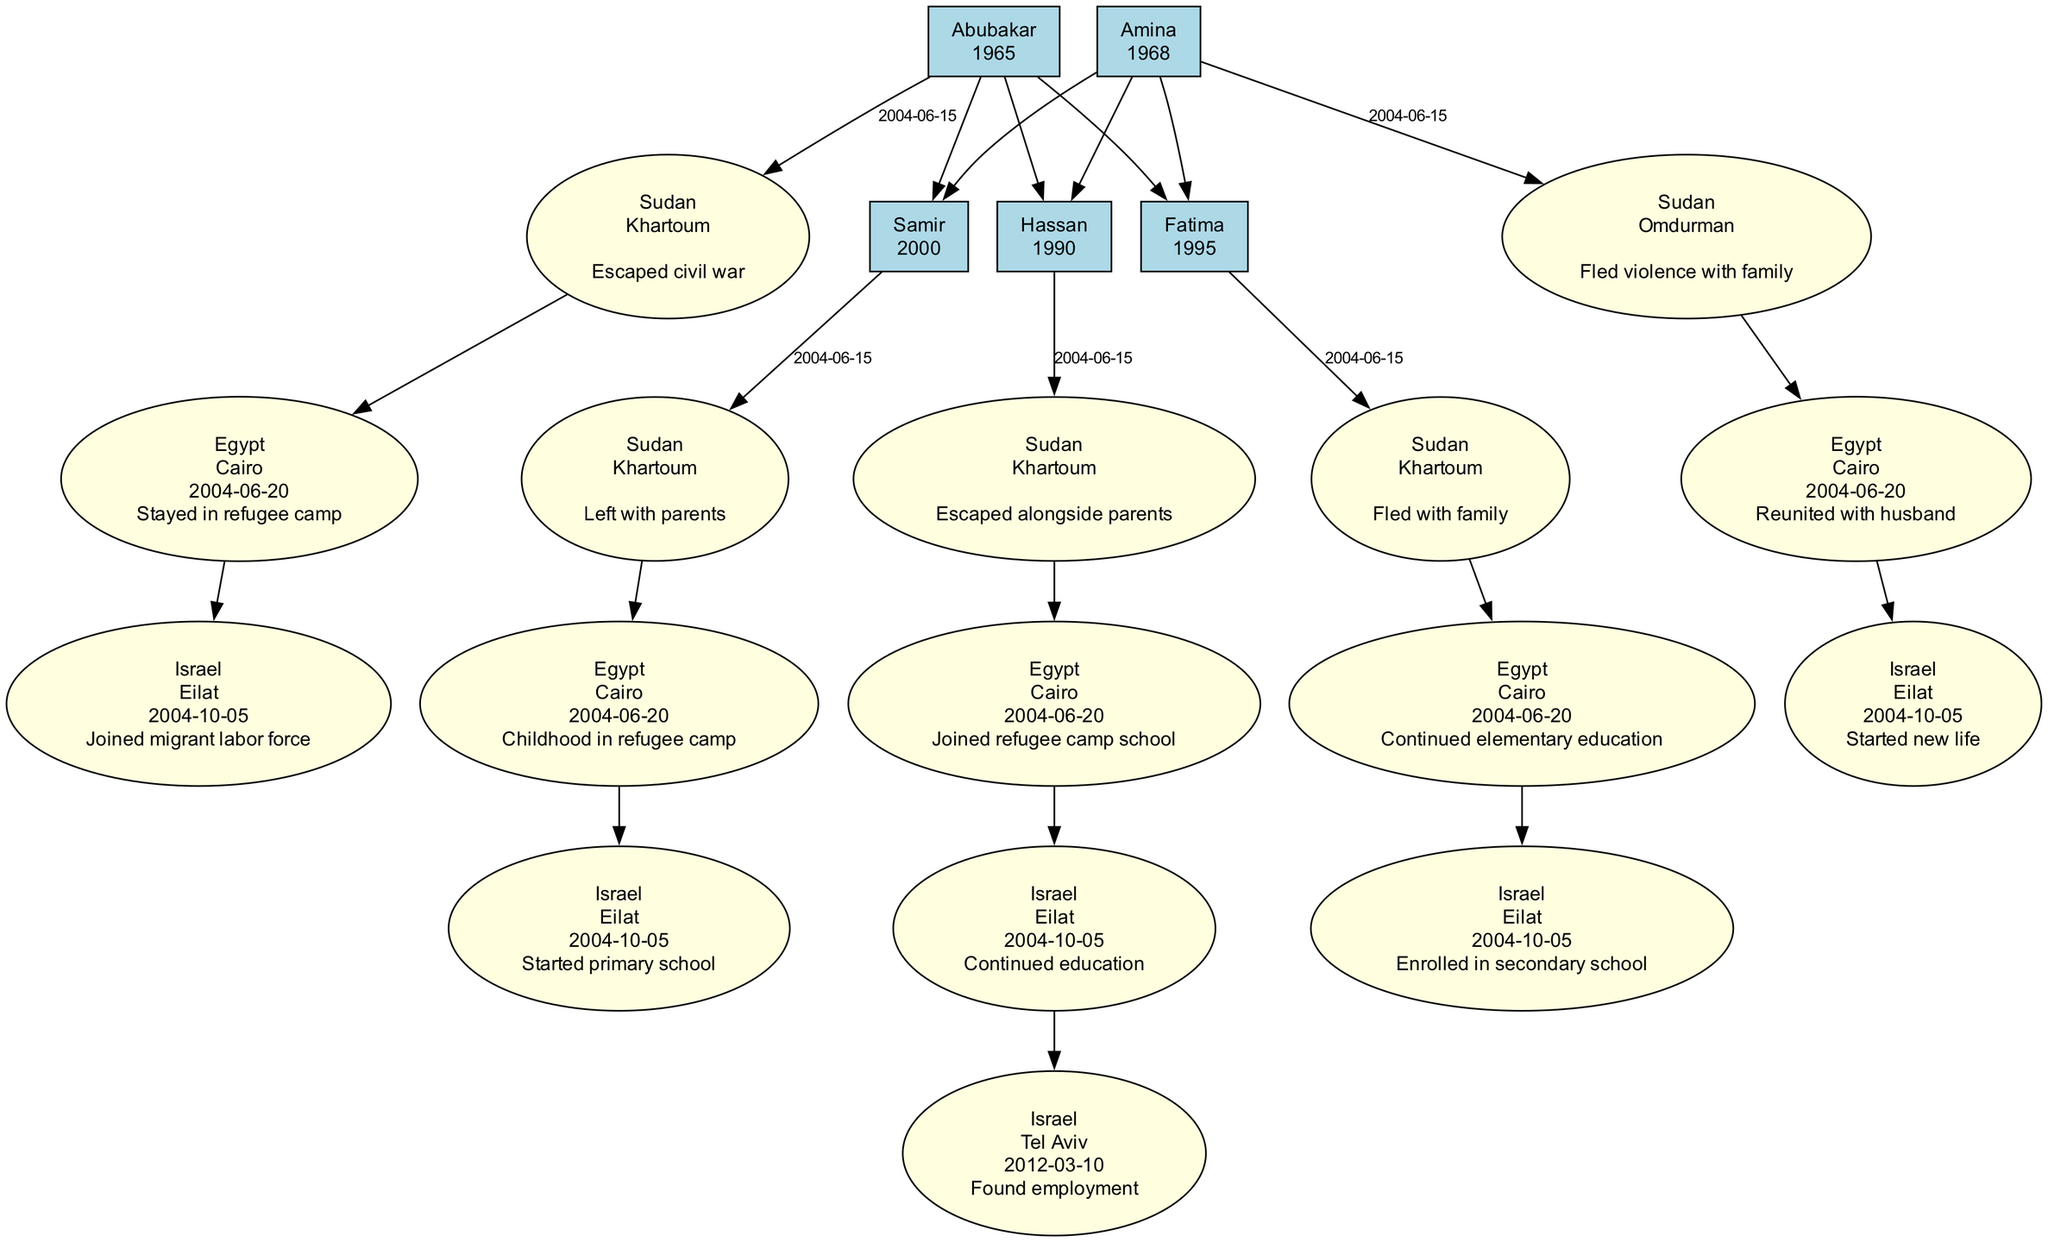What is the name of the patriarch in the family tree? The diagram displays the patriarch's name at the top node labeled as "Patriarch". By observing this node, we find that his name is "Abubakar."
Answer: Abubakar How many children does the matriarch have? The matriarch, labeled "Amina", has three connections leading down to the nodes of her children: "OldestSon", "Daughter", and "YoungestSon". Thus, by counting these edges, we conclude that Amina has three children.
Answer: 3 What significant event happened on June 15, 2004, for the patriarch? The patriarch's journey includes a step showing a significant event labeled "Escaped civil war" on the date June 15, 2004. This is directly linked to his departure from Khartoum, Sudan.
Answer: Escaped civil war Where did Fatima continue her elementary education? By referencing the journey of Fatima, we see that she was in Cairo, Egypt during the time denoted for continuing her elementary education when she stayed in the refugee camp. It is specified in her route from Sudan to Egypt.
Answer: Cairo What is the last destination for Hassan in Israel? Hassan’s journey outlines his last step when he moved to "Tel Aviv" on March 10, 2012. This marks his final significant event in Israel, where he found employment.
Answer: Tel Aviv Which family member was born in 1995? The diagram specifies the birth years next to each family member's name. By checking the name associated with the birth year 1995, we identify that "Fatima" was born in that year.
Answer: Fatima How many migration routes did the youngest son take? Upon examining Samir's migration journey in the diagram, we can see he has three distinct migration routes listed: from Sudan to Egypt, and then to Israel. Therefore, by counting these routes, we find that he took three migration routes.
Answer: 3 What significant event did Amina experience in Cairo? In Amina's journey, there is a specific event noted in her timeline stating "Reunited with husband" during her stay in Cairo, Egypt. This event directly follows her arrival there.
Answer: Reunited with husband Which family member joined a refugee camp school in Cairo? The journey for "Hassan" highlights that he joined a refugee camp school while in "Cairo" between June 20 and September 12, 2004. This information is explicitly stated in his migration routes.
Answer: Hassan 